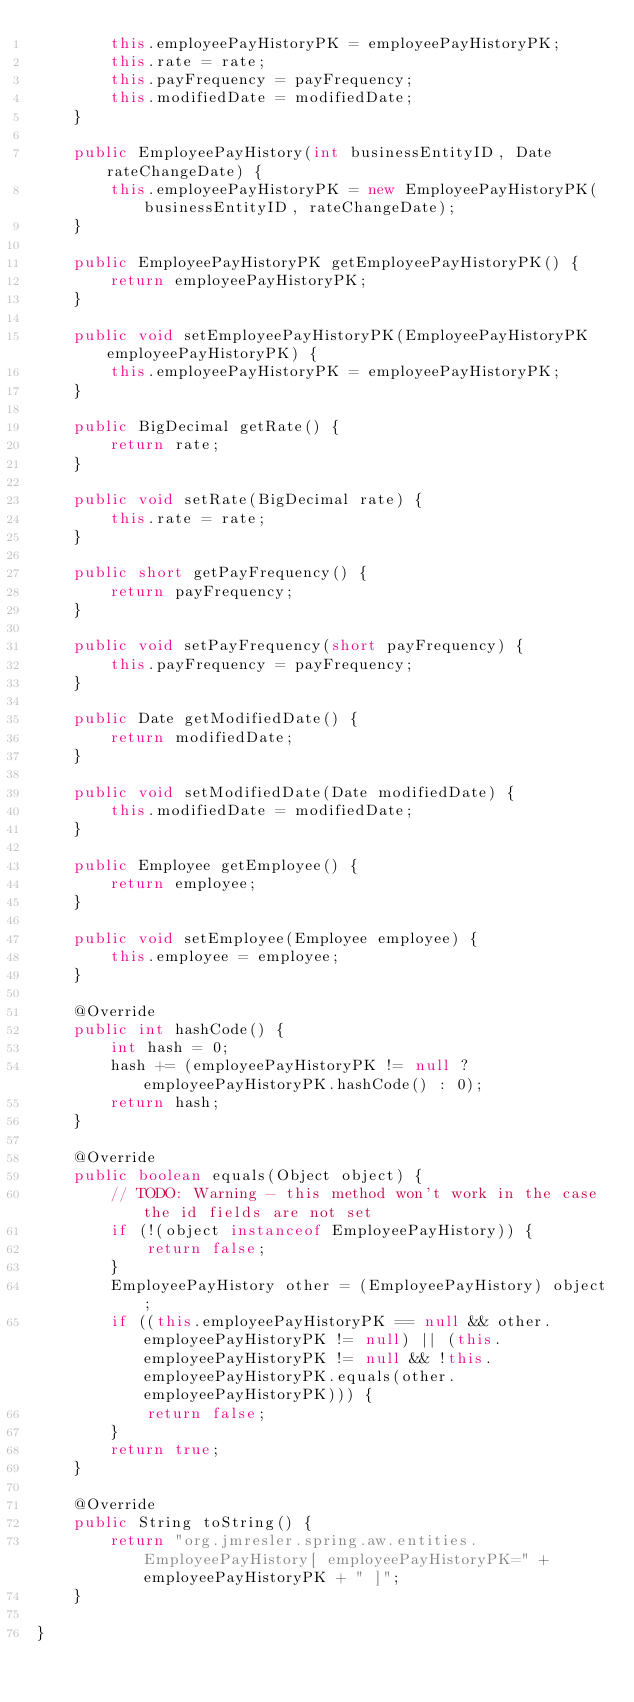<code> <loc_0><loc_0><loc_500><loc_500><_Java_>        this.employeePayHistoryPK = employeePayHistoryPK;
        this.rate = rate;
        this.payFrequency = payFrequency;
        this.modifiedDate = modifiedDate;
    }

    public EmployeePayHistory(int businessEntityID, Date rateChangeDate) {
        this.employeePayHistoryPK = new EmployeePayHistoryPK(businessEntityID, rateChangeDate);
    }

    public EmployeePayHistoryPK getEmployeePayHistoryPK() {
        return employeePayHistoryPK;
    }

    public void setEmployeePayHistoryPK(EmployeePayHistoryPK employeePayHistoryPK) {
        this.employeePayHistoryPK = employeePayHistoryPK;
    }

    public BigDecimal getRate() {
        return rate;
    }

    public void setRate(BigDecimal rate) {
        this.rate = rate;
    }

    public short getPayFrequency() {
        return payFrequency;
    }

    public void setPayFrequency(short payFrequency) {
        this.payFrequency = payFrequency;
    }

    public Date getModifiedDate() {
        return modifiedDate;
    }

    public void setModifiedDate(Date modifiedDate) {
        this.modifiedDate = modifiedDate;
    }

    public Employee getEmployee() {
        return employee;
    }

    public void setEmployee(Employee employee) {
        this.employee = employee;
    }

    @Override
    public int hashCode() {
        int hash = 0;
        hash += (employeePayHistoryPK != null ? employeePayHistoryPK.hashCode() : 0);
        return hash;
    }

    @Override
    public boolean equals(Object object) {
        // TODO: Warning - this method won't work in the case the id fields are not set
        if (!(object instanceof EmployeePayHistory)) {
            return false;
        }
        EmployeePayHistory other = (EmployeePayHistory) object;
        if ((this.employeePayHistoryPK == null && other.employeePayHistoryPK != null) || (this.employeePayHistoryPK != null && !this.employeePayHistoryPK.equals(other.employeePayHistoryPK))) {
            return false;
        }
        return true;
    }

    @Override
    public String toString() {
        return "org.jmresler.spring.aw.entities.EmployeePayHistory[ employeePayHistoryPK=" + employeePayHistoryPK + " ]";
    }
    
}
</code> 